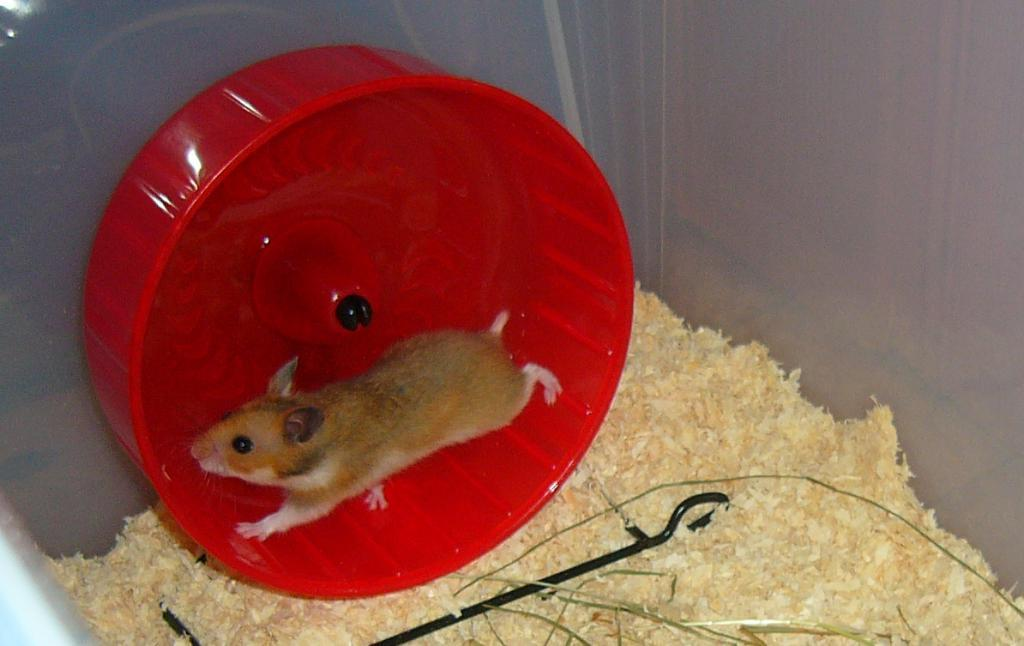What animal is present in the image? There is a rat in the image. What is the rat sitting in? The rat is in a red-colored bowl. What is at the bottom of the bowl? There is bait at the bottom of the bowl. What type of pies can be seen in the image? There are no pies present in the image. How would you describe the rat's temper in the image? The image does not provide any information about the rat's temper, as it is a still image and does not show the rat's behavior or emotions. 